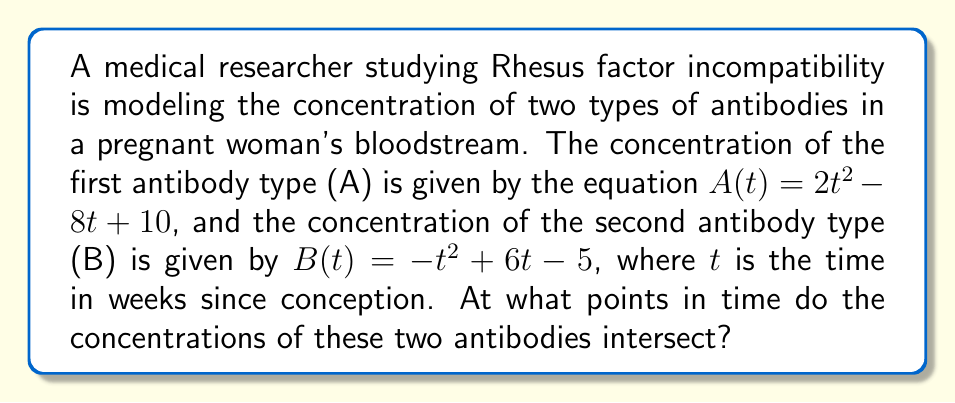Provide a solution to this math problem. To find the intersection points of these two curves, we need to solve the equation $A(t) = B(t)$:

1) Set up the equation:
   $2t^2 - 8t + 10 = -t^2 + 6t - 5$

2) Rearrange the equation to standard form:
   $2t^2 - 8t + 10 + t^2 - 6t + 5 = 0$
   $3t^2 - 14t + 15 = 0$

3) This is a quadratic equation. We can solve it using the quadratic formula:
   $t = \frac{-b \pm \sqrt{b^2 - 4ac}}{2a}$

   Where $a = 3$, $b = -14$, and $c = 15$

4) Substitute these values into the quadratic formula:
   $t = \frac{14 \pm \sqrt{(-14)^2 - 4(3)(15)}}{2(3)}$
   $t = \frac{14 \pm \sqrt{196 - 180}}{6}$
   $t = \frac{14 \pm \sqrt{16}}{6}$
   $t = \frac{14 \pm 4}{6}$

5) Simplify:
   $t = \frac{18}{6}$ or $t = \frac{10}{6}$
   $t = 3$ or $t = \frac{5}{3}$

Therefore, the antibody concentrations intersect at $t = \frac{5}{3}$ weeks and $t = 3$ weeks after conception.
Answer: $t = \frac{5}{3}$ and $t = 3$ weeks 